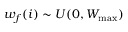<formula> <loc_0><loc_0><loc_500><loc_500>w _ { f } ( i ) \sim U ( 0 , W _ { \max } )</formula> 